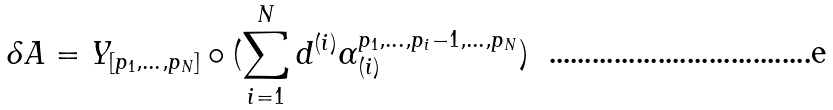Convert formula to latex. <formula><loc_0><loc_0><loc_500><loc_500>\delta A = Y _ { [ p _ { 1 } , \dots , p _ { N } ] } \circ ( \sum _ { i = 1 } ^ { N } d ^ { ( i ) } \alpha _ { ( i ) } ^ { p _ { 1 } , \dots , p _ { i } - 1 , \dots , p _ { N } } )</formula> 